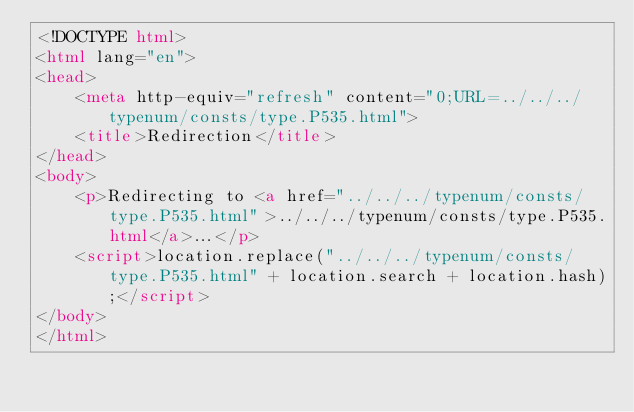Convert code to text. <code><loc_0><loc_0><loc_500><loc_500><_HTML_><!DOCTYPE html>
<html lang="en">
<head>
    <meta http-equiv="refresh" content="0;URL=../../../typenum/consts/type.P535.html">
    <title>Redirection</title>
</head>
<body>
    <p>Redirecting to <a href="../../../typenum/consts/type.P535.html">../../../typenum/consts/type.P535.html</a>...</p>
    <script>location.replace("../../../typenum/consts/type.P535.html" + location.search + location.hash);</script>
</body>
</html></code> 